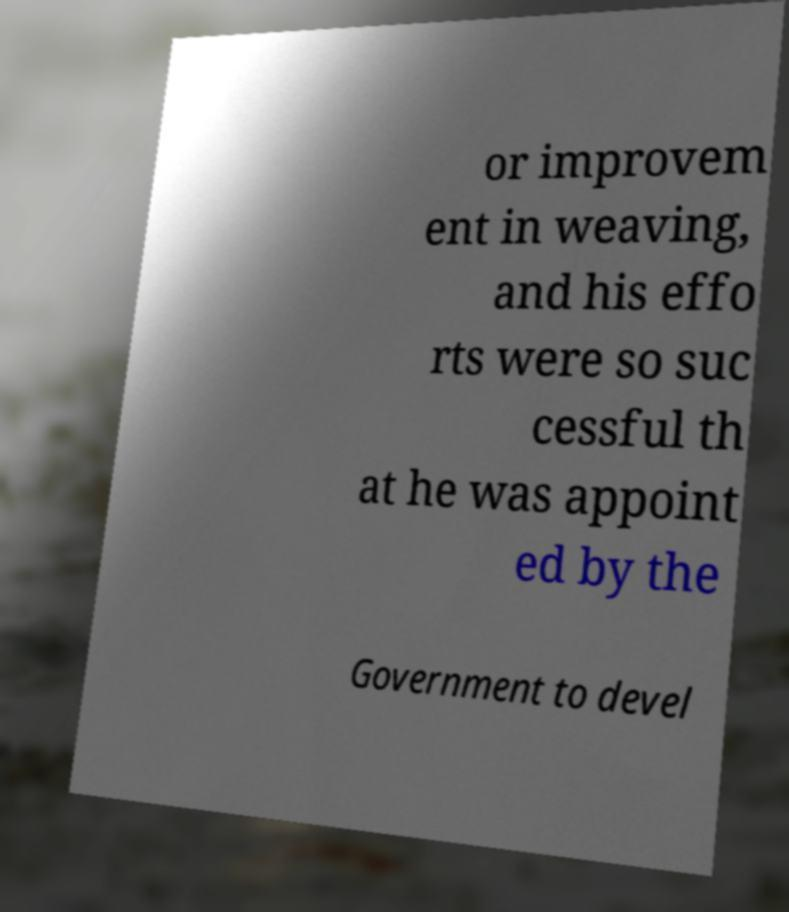Can you read and provide the text displayed in the image?This photo seems to have some interesting text. Can you extract and type it out for me? or improvem ent in weaving, and his effo rts were so suc cessful th at he was appoint ed by the Government to devel 